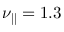Convert formula to latex. <formula><loc_0><loc_0><loc_500><loc_500>\nu _ { \| } = 1 . 3</formula> 